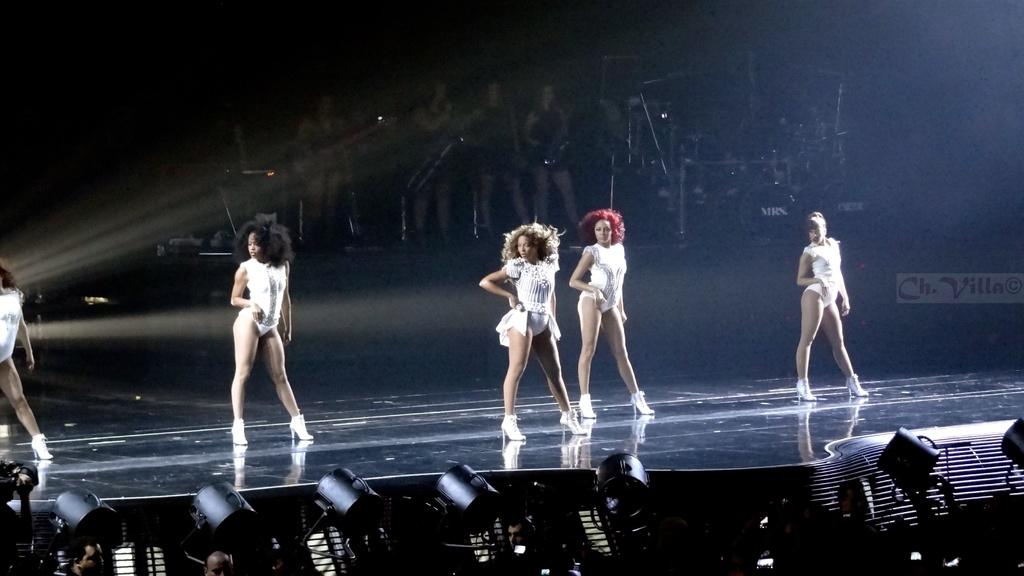What are the people on the stage doing in the image? The people on the stage are dancing in the image. What are the people in the background doing? The people in the background are playing musical instruments in the image. Can you describe the people at the bottom of the image? Yes, there are people visible at the bottom of the image. What can be seen in the image that provides illumination? There are lights visible in the image. What type of apparatus is being used by the dancers on the stage? There is no apparatus visible in the image; the dancers are simply dancing on the stage. Can you describe the hook that is holding up the lights in the image? There is no hook visible in the image; the lights are not shown to be suspended or held up by any visible apparatus. 